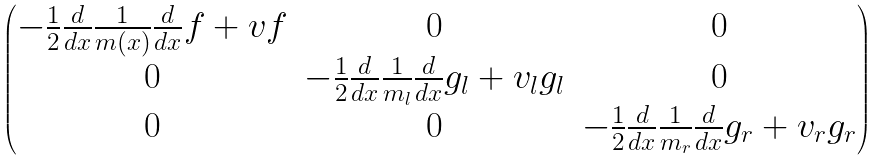<formula> <loc_0><loc_0><loc_500><loc_500>\begin{pmatrix} - \frac { 1 } { 2 } \frac { d } { d x } \frac { 1 } { m ( x ) } \frac { d } { d x } f + v f & 0 & 0 \\ 0 & - \frac { 1 } { 2 } \frac { d } { d x } \frac { 1 } { m _ { l } } \frac { d } { d x } g _ { l } + v _ { l } g _ { l } & 0 \\ 0 & 0 & - \frac { 1 } { 2 } \frac { d } { d x } \frac { 1 } { m _ { r } } \frac { d } { d x } g _ { r } + v _ { r } g _ { r } \end{pmatrix}</formula> 